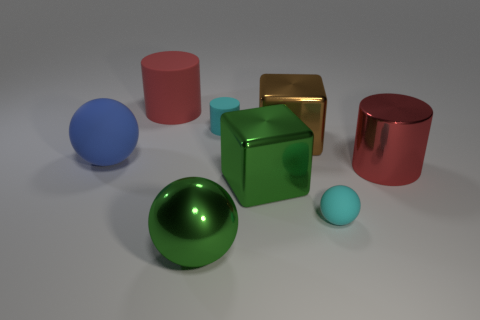I'm curious about the textures of the objects. Can you differentiate them based on their shininess? Certainly! The objects' textures vary between shiny and matte. The large green sphere, the cube, and one of the cylinders have shiny surfaces that reflect the light. The other objects, including the blue sphere and the remaining cylinders, have a matte texture which diffuses the light. 